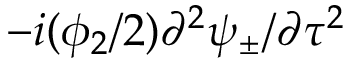Convert formula to latex. <formula><loc_0><loc_0><loc_500><loc_500>- i ( \phi _ { 2 } / 2 ) \partial ^ { 2 } \psi _ { \pm } / \partial \tau ^ { 2 }</formula> 